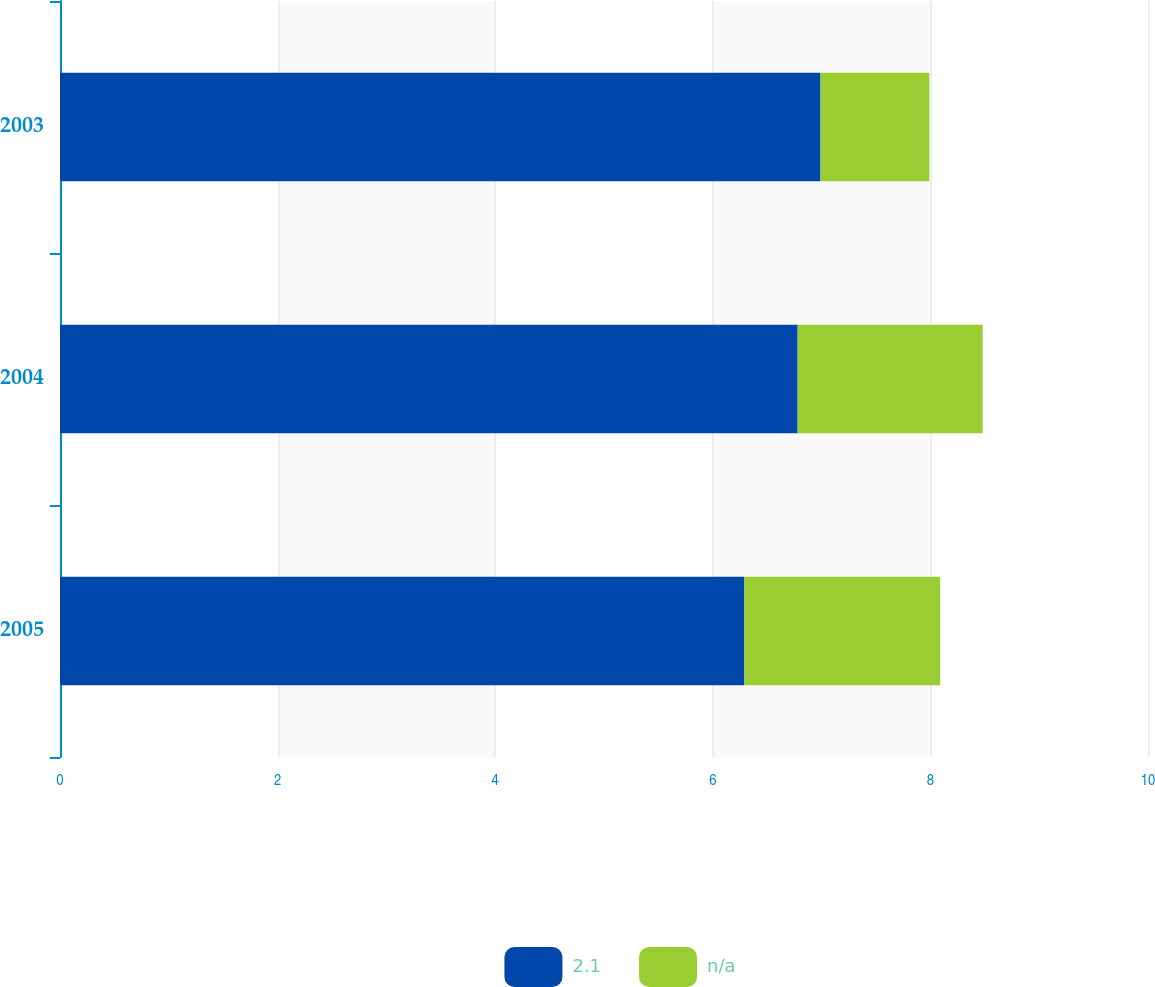Convert chart. <chart><loc_0><loc_0><loc_500><loc_500><stacked_bar_chart><ecel><fcel>2005<fcel>2004<fcel>2003<nl><fcel>2.1<fcel>6.29<fcel>6.78<fcel>6.99<nl><fcel>nan<fcel>1.8<fcel>1.7<fcel>1<nl></chart> 